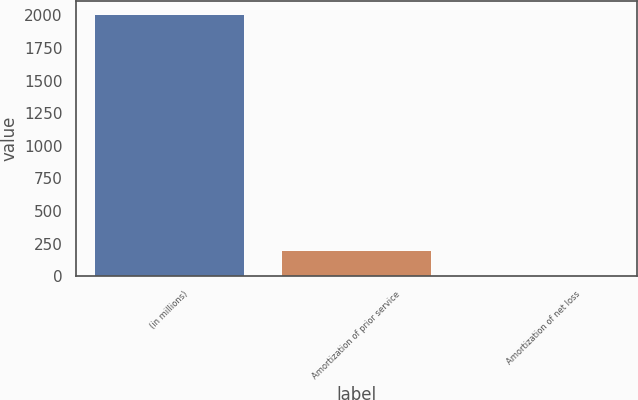<chart> <loc_0><loc_0><loc_500><loc_500><bar_chart><fcel>(in millions)<fcel>Amortization of prior service<fcel>Amortization of net loss<nl><fcel>2010<fcel>201.9<fcel>1<nl></chart> 